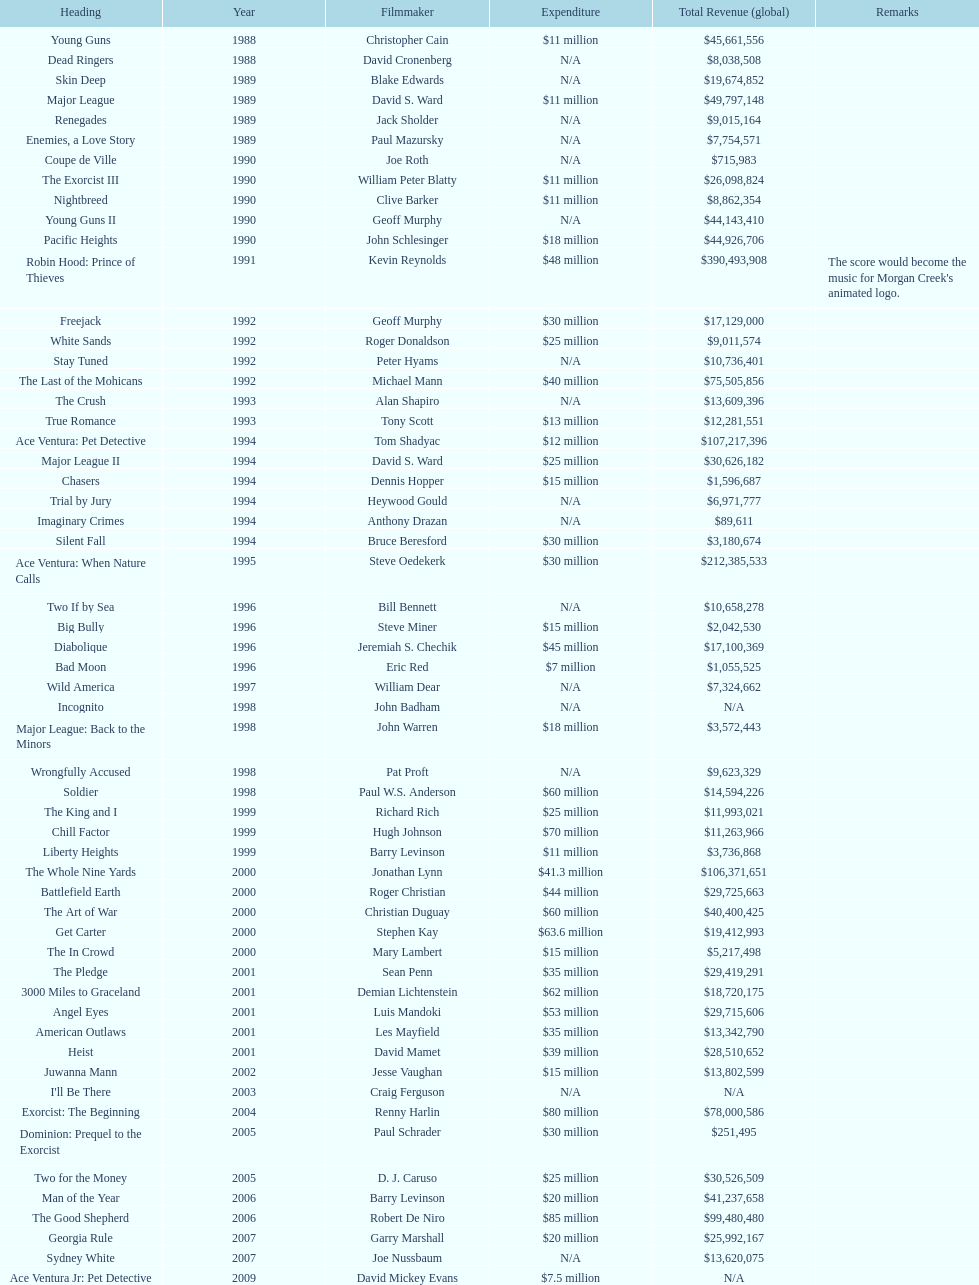For morgan creek productions, which film earned the most globally? Robin Hood: Prince of Thieves. 